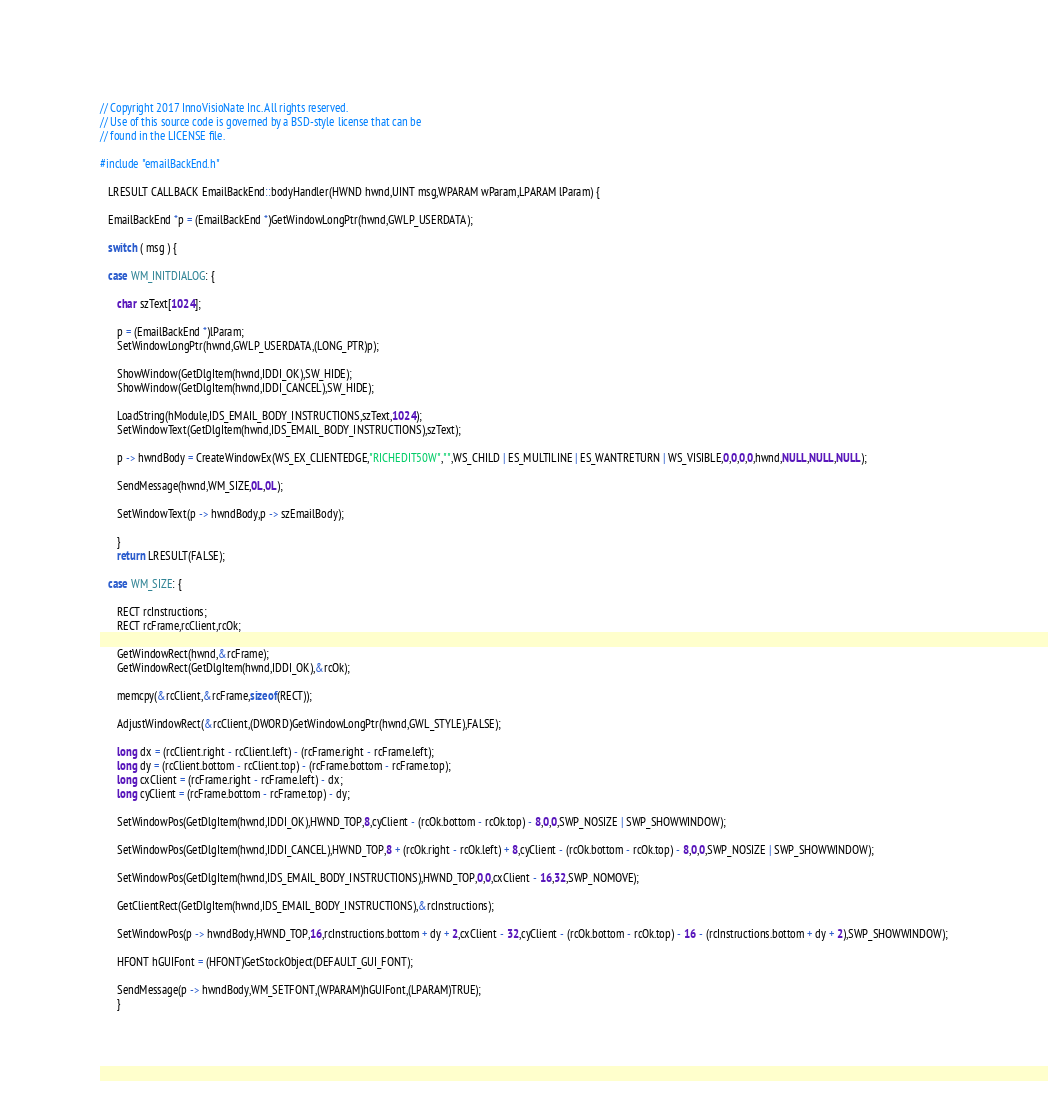Convert code to text. <code><loc_0><loc_0><loc_500><loc_500><_C++_>// Copyright 2017 InnoVisioNate Inc. All rights reserved.
// Use of this source code is governed by a BSD-style license that can be
// found in the LICENSE file.

#include "emailBackEnd.h"

   LRESULT CALLBACK EmailBackEnd::bodyHandler(HWND hwnd,UINT msg,WPARAM wParam,LPARAM lParam) {

   EmailBackEnd *p = (EmailBackEnd *)GetWindowLongPtr(hwnd,GWLP_USERDATA);

   switch ( msg ) {

   case WM_INITDIALOG: {

      char szText[1024];

      p = (EmailBackEnd *)lParam;
      SetWindowLongPtr(hwnd,GWLP_USERDATA,(LONG_PTR)p);

      ShowWindow(GetDlgItem(hwnd,IDDI_OK),SW_HIDE);
      ShowWindow(GetDlgItem(hwnd,IDDI_CANCEL),SW_HIDE);

      LoadString(hModule,IDS_EMAIL_BODY_INSTRUCTIONS,szText,1024);
      SetWindowText(GetDlgItem(hwnd,IDS_EMAIL_BODY_INSTRUCTIONS),szText);

      p -> hwndBody = CreateWindowEx(WS_EX_CLIENTEDGE,"RICHEDIT50W","",WS_CHILD | ES_MULTILINE | ES_WANTRETURN | WS_VISIBLE,0,0,0,0,hwnd,NULL,NULL,NULL);

      SendMessage(hwnd,WM_SIZE,0L,0L);

      SetWindowText(p -> hwndBody,p -> szEmailBody);

      }
      return LRESULT(FALSE);

   case WM_SIZE: {

      RECT rcInstructions;
      RECT rcFrame,rcClient,rcOk;

      GetWindowRect(hwnd,&rcFrame);
      GetWindowRect(GetDlgItem(hwnd,IDDI_OK),&rcOk);

      memcpy(&rcClient,&rcFrame,sizeof(RECT));

      AdjustWindowRect(&rcClient,(DWORD)GetWindowLongPtr(hwnd,GWL_STYLE),FALSE);

      long dx = (rcClient.right - rcClient.left) - (rcFrame.right - rcFrame.left);
      long dy = (rcClient.bottom - rcClient.top) - (rcFrame.bottom - rcFrame.top);
      long cxClient = (rcFrame.right - rcFrame.left) - dx;
      long cyClient = (rcFrame.bottom - rcFrame.top) - dy;

      SetWindowPos(GetDlgItem(hwnd,IDDI_OK),HWND_TOP,8,cyClient - (rcOk.bottom - rcOk.top) - 8,0,0,SWP_NOSIZE | SWP_SHOWWINDOW);

      SetWindowPos(GetDlgItem(hwnd,IDDI_CANCEL),HWND_TOP,8 + (rcOk.right - rcOk.left) + 8,cyClient - (rcOk.bottom - rcOk.top) - 8,0,0,SWP_NOSIZE | SWP_SHOWWINDOW);

      SetWindowPos(GetDlgItem(hwnd,IDS_EMAIL_BODY_INSTRUCTIONS),HWND_TOP,0,0,cxClient - 16,32,SWP_NOMOVE);

      GetClientRect(GetDlgItem(hwnd,IDS_EMAIL_BODY_INSTRUCTIONS),&rcInstructions);

      SetWindowPos(p -> hwndBody,HWND_TOP,16,rcInstructions.bottom + dy + 2,cxClient - 32,cyClient - (rcOk.bottom - rcOk.top) - 16 - (rcInstructions.bottom + dy + 2),SWP_SHOWWINDOW);

      HFONT hGUIFont = (HFONT)GetStockObject(DEFAULT_GUI_FONT);

      SendMessage(p -> hwndBody,WM_SETFONT,(WPARAM)hGUIFont,(LPARAM)TRUE);
      }</code> 